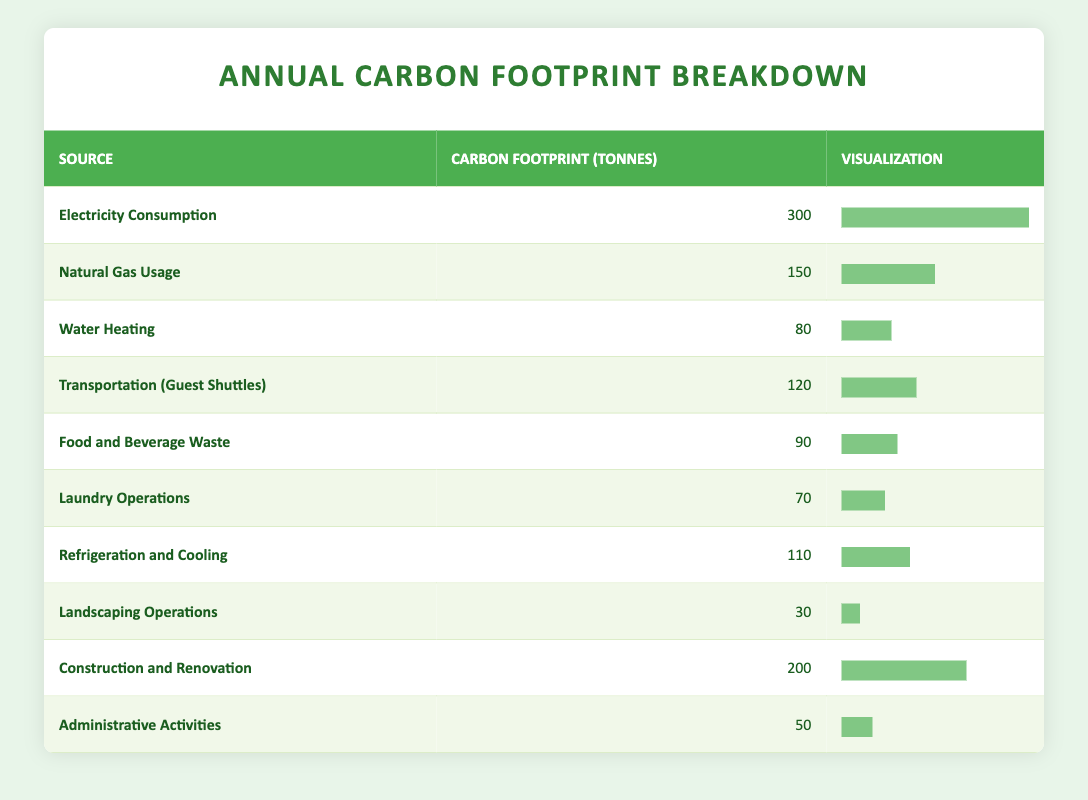What is the carbon footprint from Electricity Consumption? According to the table, the value listed for "Electricity Consumption" is 300 tonnes.
Answer: 300 tonnes Which source has the lowest carbon footprint? The source with the lowest value in the table is "Landscaping Operations," which has a carbon footprint of 30 tonnes.
Answer: Landscaping Operations What is the total carbon footprint from all sources? To find the total, sum all the carbon footprints: 300 + 150 + 80 + 120 + 90 + 70 + 110 + 30 + 200 + 50 = 1,200 tonnes.
Answer: 1,200 tonnes Is the carbon footprint from Food and Beverage Waste greater than that from Laundry Operations? The carbon footprint for "Food and Beverage Waste" is 90 tonnes, and for "Laundry Operations," it is 70 tonnes. Since 90 > 70, the statement is true.
Answer: Yes What percentage of the total carbon footprint is attributed to Natural Gas Usage? First, we find the carbon footprint from Natural Gas Usage, which is 150 tonnes. Then we calculate the percentage: (150 / 1200) * 100 = 12.5%.
Answer: 12.5% How much more carbon footprint does Construction and Renovation produce compared to Administrative Activities? The carbon footprint for "Construction and Renovation" is 200 tonnes, and for "Administrative Activities," it is 50 tonnes. So, the difference is 200 - 50 = 150 tonnes.
Answer: 150 tonnes Which source contributes more to the carbon footprint: Transportation (Guest Shuttles) or Refrigeration and Cooling? The carbon footprint for "Transportation (Guest Shuttles)" is 120 tonnes, and for "Refrigeration and Cooling," it is 110 tonnes. Thus, "Transportation (Guest Shuttles)" contributes more.
Answer: Transportation (Guest Shuttles) What is the average carbon footprint of the sources listed in the table? To find the average, sum all the footprints (1,200 tonnes) and divide by the number of sources (10): 1200 / 10 = 120 tonnes.
Answer: 120 tonnes Does the carbon footprint from Water Heating exceed the average carbon footprint of all sources? The average calculated is 120 tonnes. The carbon footprint from "Water Heating" is 80 tonnes, which is not greater than the average.
Answer: No How do the carbon footprints of Landscaping Operations and Laundry Operations compare? The carbon footprint for "Landscaping Operations" is 30 tonnes, and for "Laundry Operations," it is 70 tonnes. Therefore, "Laundry Operations" has a higher carbon footprint, specifically 70 - 30 = 40 tonnes more.
Answer: Laundry Operations has a higher footprint by 40 tonnes 